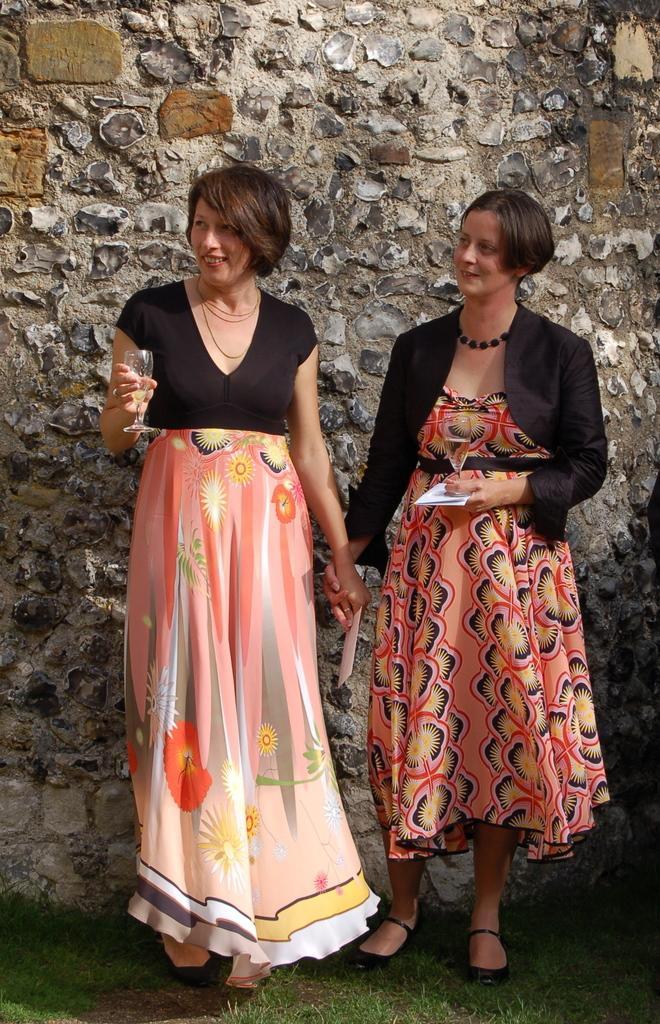How would you summarize this image in a sentence or two? In this image there are two girls who are standing one beside the other. In the background there is a wall. The girl on the right side is holding the paper, while the girl on the left side is holding the glass. 